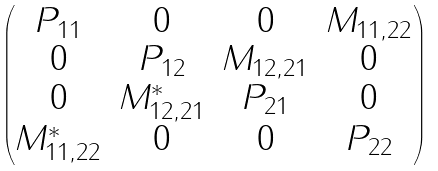Convert formula to latex. <formula><loc_0><loc_0><loc_500><loc_500>\begin{pmatrix} P _ { 1 1 } & 0 & 0 & M _ { 1 1 , 2 2 } \\ 0 & P _ { 1 2 } & M _ { 1 2 , 2 1 } & 0 \\ 0 & M _ { 1 2 , 2 1 } ^ { * } & P _ { 2 1 } & 0 \\ M _ { 1 1 , 2 2 } ^ { * } & 0 & 0 & P _ { 2 2 } \end{pmatrix}</formula> 